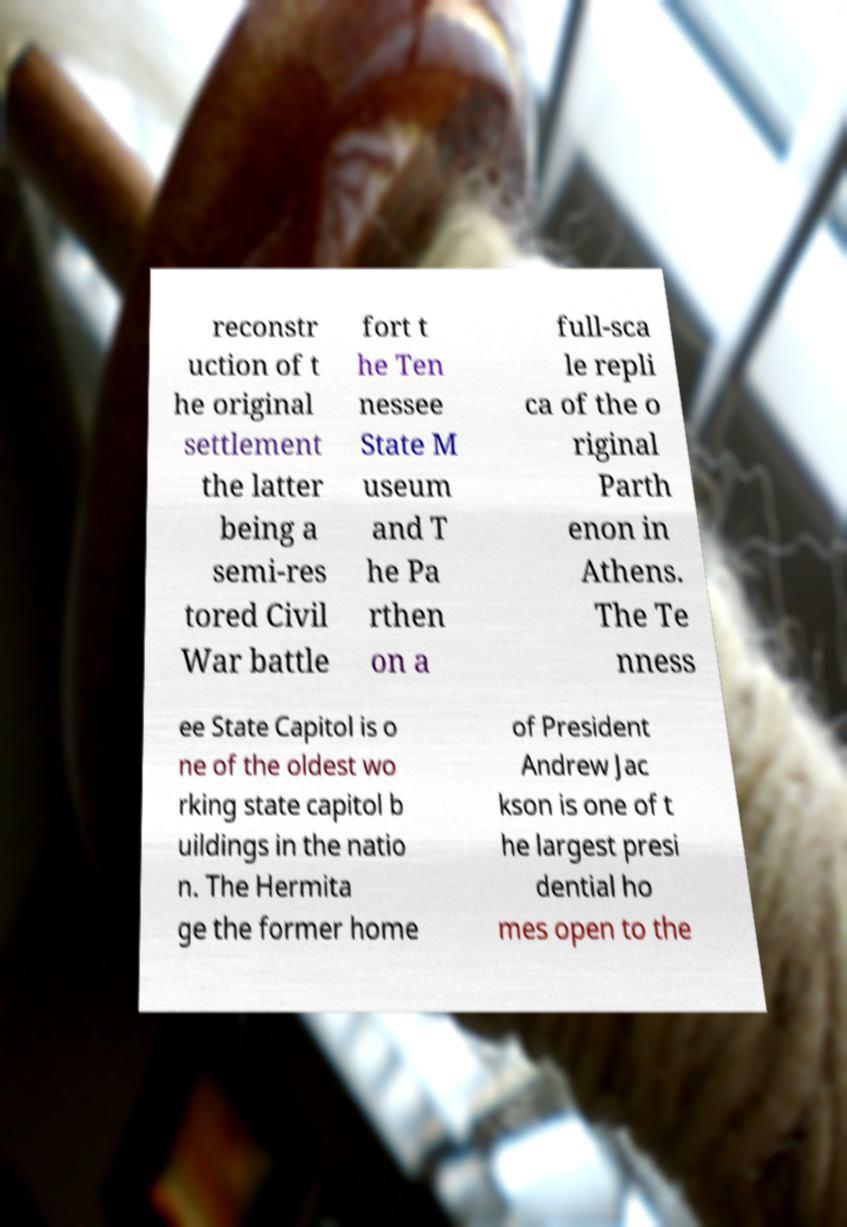Please read and relay the text visible in this image. What does it say? reconstr uction of t he original settlement the latter being a semi-res tored Civil War battle fort t he Ten nessee State M useum and T he Pa rthen on a full-sca le repli ca of the o riginal Parth enon in Athens. The Te nness ee State Capitol is o ne of the oldest wo rking state capitol b uildings in the natio n. The Hermita ge the former home of President Andrew Jac kson is one of t he largest presi dential ho mes open to the 